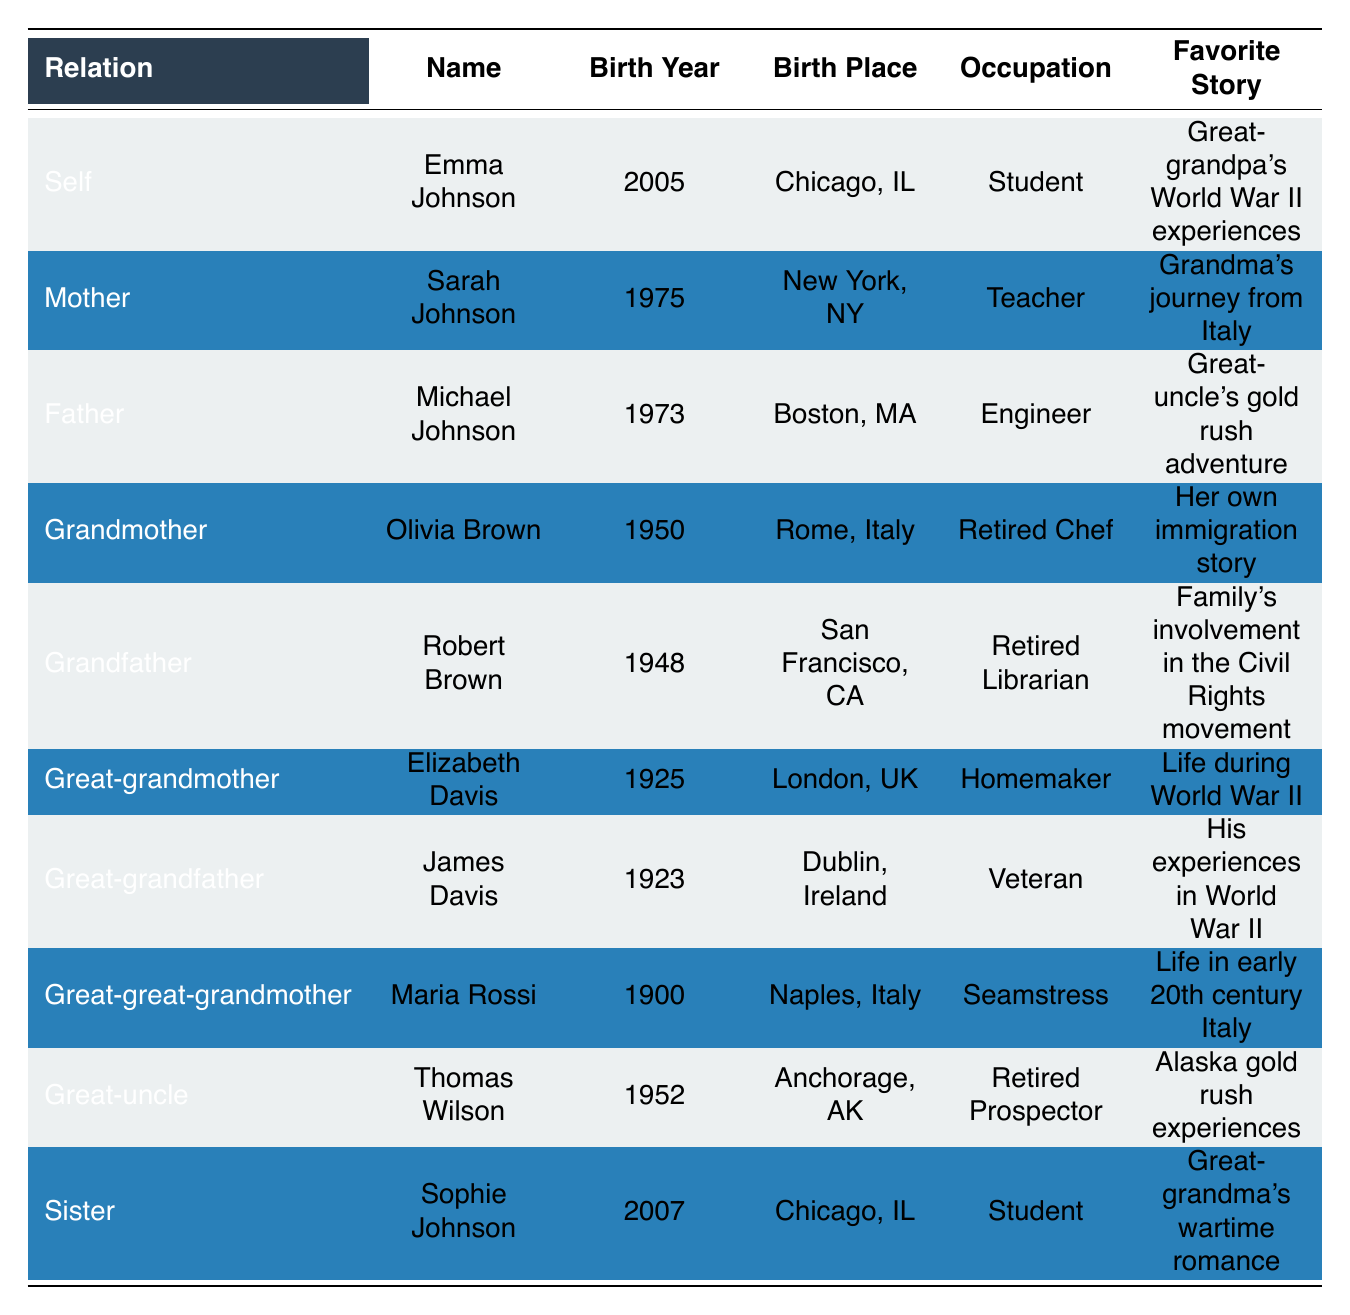What is Emma Johnson's birth place? From the table, we can find the row for Emma Johnson under the "Name" column. The "Birth Place" for that row is listed as "Chicago, IL".
Answer: Chicago, IL Who is the Grandfather in the family? The table contains a row labeled "Grandfather," which indicates that Robert Brown is recognized as the Grandfather.
Answer: Robert Brown What is the birth year of the Great-grandmother? Looking at the row for Great-grandmother in the table, the "Birth Year" column shows that Elizabeth Davis was born in 1925.
Answer: 1925 How many family members were born in the 2000s? We check each row for members born in the 2000s. Only Emma Johnson (2005) and Sophie Johnson (2007) meet this criterion, so there are two family members in this category.
Answer: 2 Is Sarah Johnson a teacher? In the table, Sarah Johnson's occupation is stated under the "Occupation" column, confirming that she is indeed a Teacher.
Answer: Yes Who has the favorite story about the Civil Rights movement? To find this, we look at the row for Grandfather Robert Brown. His "Favorite Story" column specifies that it is about the family's involvement in the Civil Rights movement.
Answer: Robert Brown What is the average birth year of the grandparents? We look at the birth years of both grandparents: Olivia Brown (1950) and Robert Brown (1948). Adding these years gives 1950 + 1948 = 3998. Dividing by 2 gives an average of 1999.
Answer: 1949 Which family member is a student? By scanning the table, we find that both Emma Johnson and Sophie Johnson are labeled as "Students" in the "Occupation" column.
Answer: Emma Johnson and Sophie Johnson What is the favorite story of the Great-uncle? Referencing the row for Great-uncle Thomas Wilson, his "Favorite Story" is specifically listed as his Alaska gold rush experiences.
Answer: Alaska gold rush experiences 